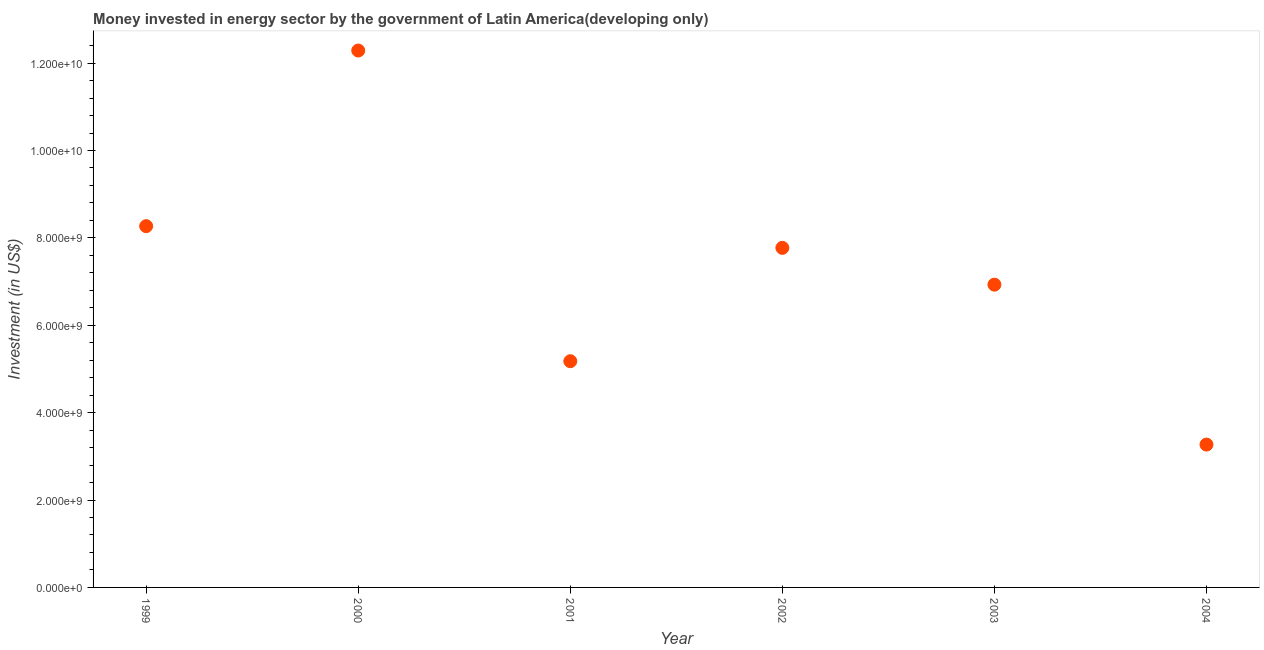What is the investment in energy in 2001?
Your response must be concise. 5.18e+09. Across all years, what is the maximum investment in energy?
Offer a very short reply. 1.23e+1. Across all years, what is the minimum investment in energy?
Provide a succinct answer. 3.27e+09. In which year was the investment in energy minimum?
Keep it short and to the point. 2004. What is the sum of the investment in energy?
Your answer should be very brief. 4.37e+1. What is the difference between the investment in energy in 2000 and 2003?
Your answer should be very brief. 5.36e+09. What is the average investment in energy per year?
Provide a short and direct response. 7.28e+09. What is the median investment in energy?
Provide a succinct answer. 7.35e+09. In how many years, is the investment in energy greater than 4400000000 US$?
Your answer should be compact. 5. Do a majority of the years between 2000 and 2004 (inclusive) have investment in energy greater than 4000000000 US$?
Give a very brief answer. Yes. What is the ratio of the investment in energy in 2000 to that in 2004?
Offer a terse response. 3.76. Is the difference between the investment in energy in 2001 and 2003 greater than the difference between any two years?
Provide a succinct answer. No. What is the difference between the highest and the second highest investment in energy?
Make the answer very short. 4.02e+09. Is the sum of the investment in energy in 1999 and 2000 greater than the maximum investment in energy across all years?
Provide a succinct answer. Yes. What is the difference between the highest and the lowest investment in energy?
Provide a short and direct response. 9.02e+09. How many years are there in the graph?
Give a very brief answer. 6. What is the difference between two consecutive major ticks on the Y-axis?
Offer a terse response. 2.00e+09. Are the values on the major ticks of Y-axis written in scientific E-notation?
Offer a very short reply. Yes. What is the title of the graph?
Provide a succinct answer. Money invested in energy sector by the government of Latin America(developing only). What is the label or title of the Y-axis?
Offer a terse response. Investment (in US$). What is the Investment (in US$) in 1999?
Offer a very short reply. 8.27e+09. What is the Investment (in US$) in 2000?
Give a very brief answer. 1.23e+1. What is the Investment (in US$) in 2001?
Provide a succinct answer. 5.18e+09. What is the Investment (in US$) in 2002?
Offer a terse response. 7.77e+09. What is the Investment (in US$) in 2003?
Make the answer very short. 6.93e+09. What is the Investment (in US$) in 2004?
Keep it short and to the point. 3.27e+09. What is the difference between the Investment (in US$) in 1999 and 2000?
Provide a short and direct response. -4.02e+09. What is the difference between the Investment (in US$) in 1999 and 2001?
Your answer should be compact. 3.09e+09. What is the difference between the Investment (in US$) in 1999 and 2002?
Make the answer very short. 4.96e+08. What is the difference between the Investment (in US$) in 1999 and 2003?
Offer a very short reply. 1.34e+09. What is the difference between the Investment (in US$) in 1999 and 2004?
Offer a very short reply. 5.00e+09. What is the difference between the Investment (in US$) in 2000 and 2001?
Your response must be concise. 7.11e+09. What is the difference between the Investment (in US$) in 2000 and 2002?
Your answer should be very brief. 4.52e+09. What is the difference between the Investment (in US$) in 2000 and 2003?
Ensure brevity in your answer.  5.36e+09. What is the difference between the Investment (in US$) in 2000 and 2004?
Provide a short and direct response. 9.02e+09. What is the difference between the Investment (in US$) in 2001 and 2002?
Give a very brief answer. -2.59e+09. What is the difference between the Investment (in US$) in 2001 and 2003?
Make the answer very short. -1.75e+09. What is the difference between the Investment (in US$) in 2001 and 2004?
Your answer should be very brief. 1.91e+09. What is the difference between the Investment (in US$) in 2002 and 2003?
Ensure brevity in your answer.  8.42e+08. What is the difference between the Investment (in US$) in 2002 and 2004?
Make the answer very short. 4.50e+09. What is the difference between the Investment (in US$) in 2003 and 2004?
Offer a very short reply. 3.66e+09. What is the ratio of the Investment (in US$) in 1999 to that in 2000?
Offer a very short reply. 0.67. What is the ratio of the Investment (in US$) in 1999 to that in 2001?
Ensure brevity in your answer.  1.6. What is the ratio of the Investment (in US$) in 1999 to that in 2002?
Ensure brevity in your answer.  1.06. What is the ratio of the Investment (in US$) in 1999 to that in 2003?
Provide a succinct answer. 1.19. What is the ratio of the Investment (in US$) in 1999 to that in 2004?
Provide a short and direct response. 2.53. What is the ratio of the Investment (in US$) in 2000 to that in 2001?
Offer a very short reply. 2.37. What is the ratio of the Investment (in US$) in 2000 to that in 2002?
Your response must be concise. 1.58. What is the ratio of the Investment (in US$) in 2000 to that in 2003?
Your answer should be compact. 1.77. What is the ratio of the Investment (in US$) in 2000 to that in 2004?
Keep it short and to the point. 3.76. What is the ratio of the Investment (in US$) in 2001 to that in 2002?
Your answer should be very brief. 0.67. What is the ratio of the Investment (in US$) in 2001 to that in 2003?
Make the answer very short. 0.75. What is the ratio of the Investment (in US$) in 2001 to that in 2004?
Offer a terse response. 1.58. What is the ratio of the Investment (in US$) in 2002 to that in 2003?
Make the answer very short. 1.12. What is the ratio of the Investment (in US$) in 2002 to that in 2004?
Provide a short and direct response. 2.38. What is the ratio of the Investment (in US$) in 2003 to that in 2004?
Ensure brevity in your answer.  2.12. 